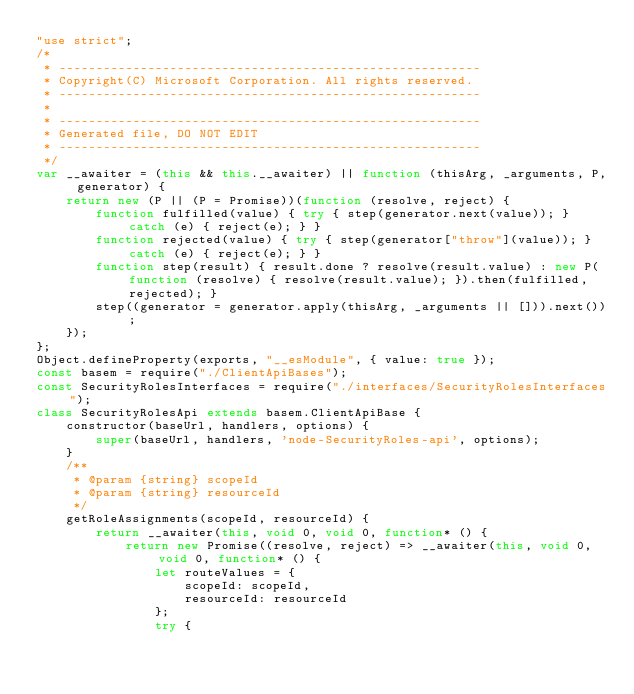Convert code to text. <code><loc_0><loc_0><loc_500><loc_500><_JavaScript_>"use strict";
/*
 * ---------------------------------------------------------
 * Copyright(C) Microsoft Corporation. All rights reserved.
 * ---------------------------------------------------------
 *
 * ---------------------------------------------------------
 * Generated file, DO NOT EDIT
 * ---------------------------------------------------------
 */
var __awaiter = (this && this.__awaiter) || function (thisArg, _arguments, P, generator) {
    return new (P || (P = Promise))(function (resolve, reject) {
        function fulfilled(value) { try { step(generator.next(value)); } catch (e) { reject(e); } }
        function rejected(value) { try { step(generator["throw"](value)); } catch (e) { reject(e); } }
        function step(result) { result.done ? resolve(result.value) : new P(function (resolve) { resolve(result.value); }).then(fulfilled, rejected); }
        step((generator = generator.apply(thisArg, _arguments || [])).next());
    });
};
Object.defineProperty(exports, "__esModule", { value: true });
const basem = require("./ClientApiBases");
const SecurityRolesInterfaces = require("./interfaces/SecurityRolesInterfaces");
class SecurityRolesApi extends basem.ClientApiBase {
    constructor(baseUrl, handlers, options) {
        super(baseUrl, handlers, 'node-SecurityRoles-api', options);
    }
    /**
     * @param {string} scopeId
     * @param {string} resourceId
     */
    getRoleAssignments(scopeId, resourceId) {
        return __awaiter(this, void 0, void 0, function* () {
            return new Promise((resolve, reject) => __awaiter(this, void 0, void 0, function* () {
                let routeValues = {
                    scopeId: scopeId,
                    resourceId: resourceId
                };
                try {</code> 